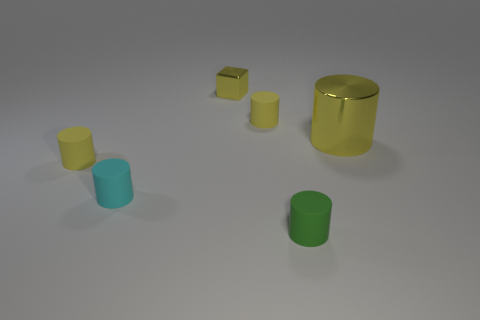Are there any other things that have the same shape as the small metal object?
Your response must be concise. No. There is a tiny cyan cylinder that is in front of the yellow thing that is to the right of the tiny green cylinder; what is it made of?
Keep it short and to the point. Rubber. How big is the yellow metal cylinder?
Provide a short and direct response. Large. What number of other matte cylinders have the same size as the green matte cylinder?
Offer a very short reply. 3. What number of yellow metal objects have the same shape as the tiny green rubber thing?
Your answer should be very brief. 1. Are there the same number of big yellow metal cylinders that are left of the tiny yellow cube and purple rubber blocks?
Provide a succinct answer. Yes. Is there any other thing that is the same size as the metallic cylinder?
Keep it short and to the point. No. What shape is the metallic object that is the same size as the green matte cylinder?
Your response must be concise. Cube. Are there any small yellow objects that have the same shape as the cyan rubber thing?
Make the answer very short. Yes. Is there a yellow cylinder that is behind the yellow rubber object that is in front of the yellow metal thing that is to the right of the green cylinder?
Provide a succinct answer. Yes. 